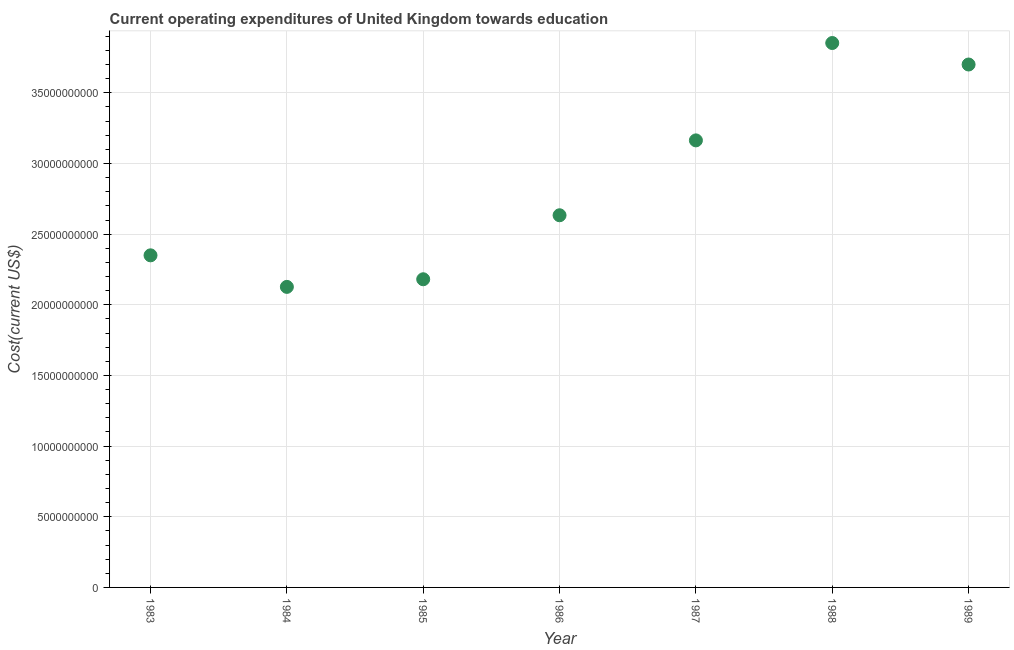What is the education expenditure in 1983?
Make the answer very short. 2.35e+1. Across all years, what is the maximum education expenditure?
Give a very brief answer. 3.85e+1. Across all years, what is the minimum education expenditure?
Make the answer very short. 2.13e+1. What is the sum of the education expenditure?
Make the answer very short. 2.00e+11. What is the difference between the education expenditure in 1987 and 1988?
Your answer should be compact. -6.89e+09. What is the average education expenditure per year?
Offer a terse response. 2.86e+1. What is the median education expenditure?
Keep it short and to the point. 2.63e+1. In how many years, is the education expenditure greater than 17000000000 US$?
Make the answer very short. 7. Do a majority of the years between 1985 and 1988 (inclusive) have education expenditure greater than 16000000000 US$?
Make the answer very short. Yes. What is the ratio of the education expenditure in 1984 to that in 1986?
Provide a short and direct response. 0.81. Is the education expenditure in 1983 less than that in 1984?
Your answer should be very brief. No. Is the difference between the education expenditure in 1984 and 1985 greater than the difference between any two years?
Give a very brief answer. No. What is the difference between the highest and the second highest education expenditure?
Offer a very short reply. 1.52e+09. What is the difference between the highest and the lowest education expenditure?
Give a very brief answer. 1.73e+1. In how many years, is the education expenditure greater than the average education expenditure taken over all years?
Offer a very short reply. 3. Does the graph contain grids?
Your response must be concise. Yes. What is the title of the graph?
Ensure brevity in your answer.  Current operating expenditures of United Kingdom towards education. What is the label or title of the Y-axis?
Give a very brief answer. Cost(current US$). What is the Cost(current US$) in 1983?
Offer a very short reply. 2.35e+1. What is the Cost(current US$) in 1984?
Your answer should be very brief. 2.13e+1. What is the Cost(current US$) in 1985?
Provide a short and direct response. 2.18e+1. What is the Cost(current US$) in 1986?
Offer a terse response. 2.63e+1. What is the Cost(current US$) in 1987?
Provide a succinct answer. 3.16e+1. What is the Cost(current US$) in 1988?
Keep it short and to the point. 3.85e+1. What is the Cost(current US$) in 1989?
Offer a very short reply. 3.70e+1. What is the difference between the Cost(current US$) in 1983 and 1984?
Offer a terse response. 2.23e+09. What is the difference between the Cost(current US$) in 1983 and 1985?
Your answer should be compact. 1.69e+09. What is the difference between the Cost(current US$) in 1983 and 1986?
Your answer should be very brief. -2.84e+09. What is the difference between the Cost(current US$) in 1983 and 1987?
Your response must be concise. -8.13e+09. What is the difference between the Cost(current US$) in 1983 and 1988?
Your response must be concise. -1.50e+1. What is the difference between the Cost(current US$) in 1983 and 1989?
Provide a short and direct response. -1.35e+1. What is the difference between the Cost(current US$) in 1984 and 1985?
Offer a terse response. -5.39e+08. What is the difference between the Cost(current US$) in 1984 and 1986?
Your response must be concise. -5.07e+09. What is the difference between the Cost(current US$) in 1984 and 1987?
Offer a terse response. -1.04e+1. What is the difference between the Cost(current US$) in 1984 and 1988?
Ensure brevity in your answer.  -1.73e+1. What is the difference between the Cost(current US$) in 1984 and 1989?
Provide a succinct answer. -1.57e+1. What is the difference between the Cost(current US$) in 1985 and 1986?
Your answer should be very brief. -4.53e+09. What is the difference between the Cost(current US$) in 1985 and 1987?
Offer a terse response. -9.83e+09. What is the difference between the Cost(current US$) in 1985 and 1988?
Provide a succinct answer. -1.67e+1. What is the difference between the Cost(current US$) in 1985 and 1989?
Keep it short and to the point. -1.52e+1. What is the difference between the Cost(current US$) in 1986 and 1987?
Provide a succinct answer. -5.30e+09. What is the difference between the Cost(current US$) in 1986 and 1988?
Provide a short and direct response. -1.22e+1. What is the difference between the Cost(current US$) in 1986 and 1989?
Provide a succinct answer. -1.07e+1. What is the difference between the Cost(current US$) in 1987 and 1988?
Offer a very short reply. -6.89e+09. What is the difference between the Cost(current US$) in 1987 and 1989?
Keep it short and to the point. -5.37e+09. What is the difference between the Cost(current US$) in 1988 and 1989?
Provide a short and direct response. 1.52e+09. What is the ratio of the Cost(current US$) in 1983 to that in 1984?
Your response must be concise. 1.1. What is the ratio of the Cost(current US$) in 1983 to that in 1985?
Offer a terse response. 1.08. What is the ratio of the Cost(current US$) in 1983 to that in 1986?
Make the answer very short. 0.89. What is the ratio of the Cost(current US$) in 1983 to that in 1987?
Keep it short and to the point. 0.74. What is the ratio of the Cost(current US$) in 1983 to that in 1988?
Your response must be concise. 0.61. What is the ratio of the Cost(current US$) in 1983 to that in 1989?
Give a very brief answer. 0.64. What is the ratio of the Cost(current US$) in 1984 to that in 1986?
Offer a terse response. 0.81. What is the ratio of the Cost(current US$) in 1984 to that in 1987?
Make the answer very short. 0.67. What is the ratio of the Cost(current US$) in 1984 to that in 1988?
Provide a short and direct response. 0.55. What is the ratio of the Cost(current US$) in 1984 to that in 1989?
Your response must be concise. 0.57. What is the ratio of the Cost(current US$) in 1985 to that in 1986?
Provide a succinct answer. 0.83. What is the ratio of the Cost(current US$) in 1985 to that in 1987?
Ensure brevity in your answer.  0.69. What is the ratio of the Cost(current US$) in 1985 to that in 1988?
Provide a succinct answer. 0.57. What is the ratio of the Cost(current US$) in 1985 to that in 1989?
Offer a terse response. 0.59. What is the ratio of the Cost(current US$) in 1986 to that in 1987?
Offer a terse response. 0.83. What is the ratio of the Cost(current US$) in 1986 to that in 1988?
Ensure brevity in your answer.  0.68. What is the ratio of the Cost(current US$) in 1986 to that in 1989?
Your answer should be very brief. 0.71. What is the ratio of the Cost(current US$) in 1987 to that in 1988?
Make the answer very short. 0.82. What is the ratio of the Cost(current US$) in 1987 to that in 1989?
Your response must be concise. 0.85. What is the ratio of the Cost(current US$) in 1988 to that in 1989?
Provide a succinct answer. 1.04. 